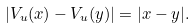Convert formula to latex. <formula><loc_0><loc_0><loc_500><loc_500>| V _ { u } ( x ) - V _ { u } ( y ) | = | x - y | .</formula> 